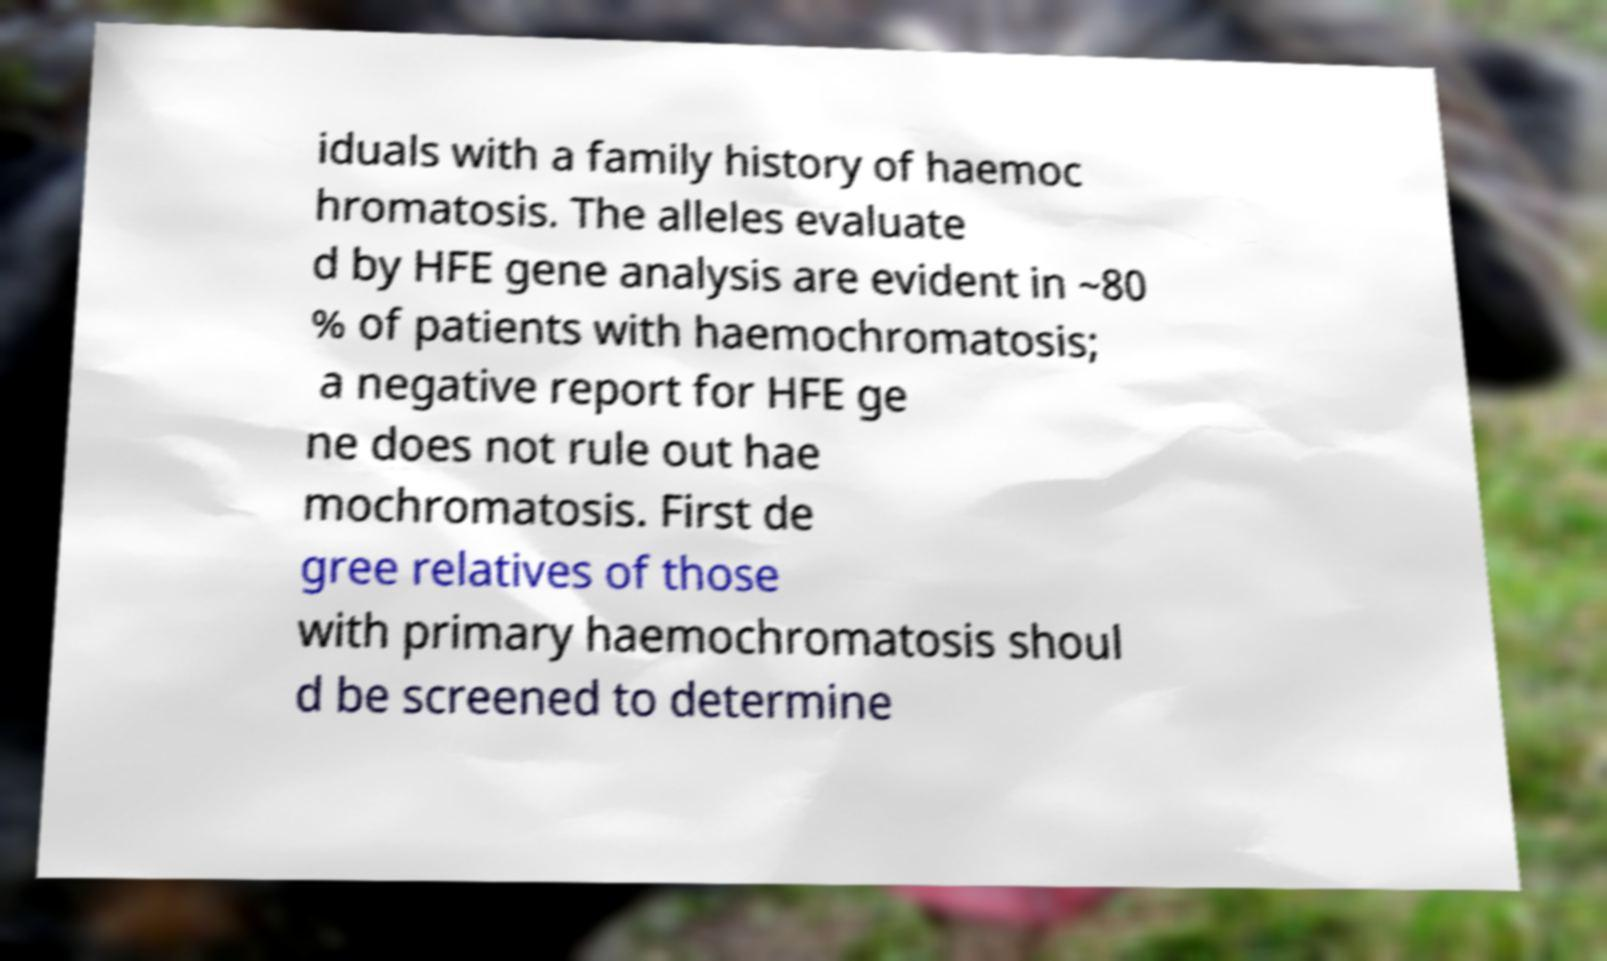Please read and relay the text visible in this image. What does it say? iduals with a family history of haemoc hromatosis. The alleles evaluate d by HFE gene analysis are evident in ~80 % of patients with haemochromatosis; a negative report for HFE ge ne does not rule out hae mochromatosis. First de gree relatives of those with primary haemochromatosis shoul d be screened to determine 